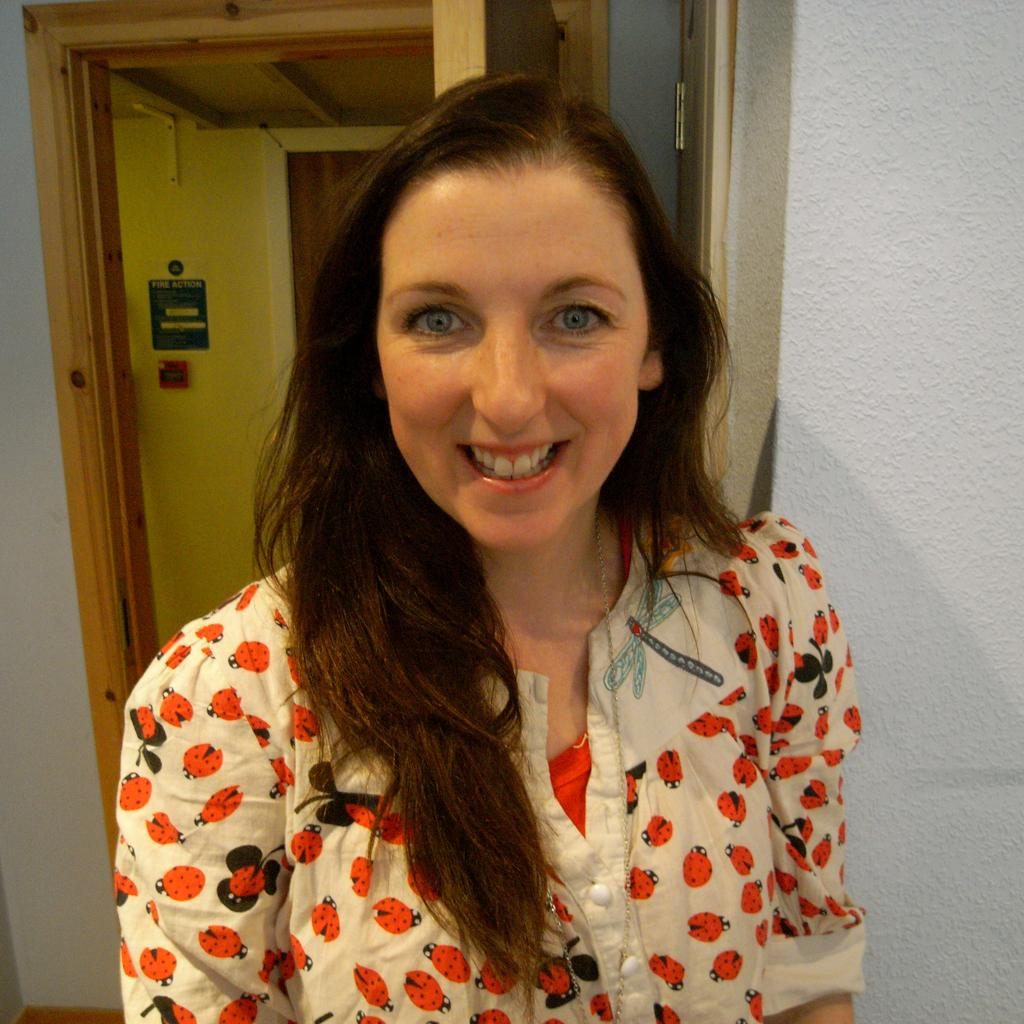Who is the main subject in the image? There is a woman in the middle of the image. What can be seen in the background of the image? There is a door in the background of the image. Where is the door located in relation to the wall? The door is near a wall. What safety device is present on the wall? There is a fire alarm on the wall. What nation is the woman representing in the image? There is no indication in the image that the woman is representing any nation. How hot is the fire alarm in the image? The fire alarm is not hot; it is an inanimate object designed to detect and alert people to the presence of fire. 